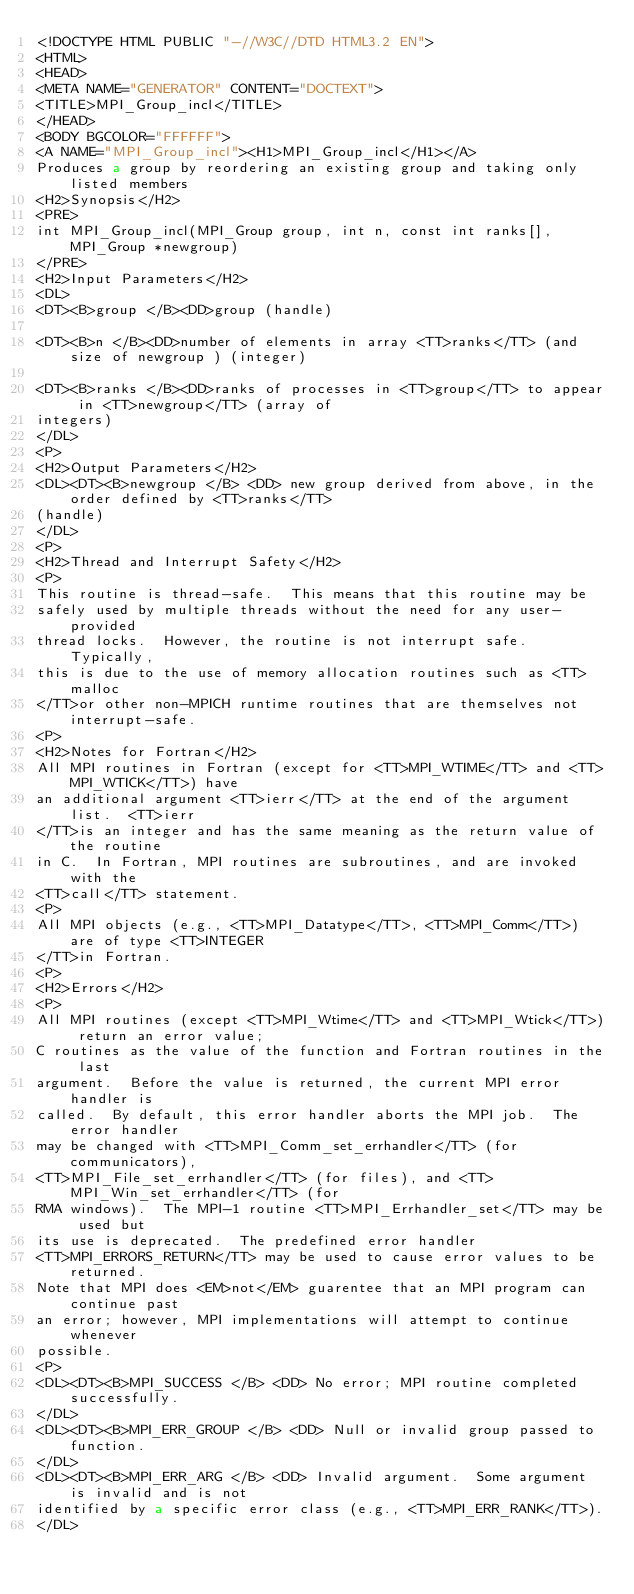<code> <loc_0><loc_0><loc_500><loc_500><_HTML_><!DOCTYPE HTML PUBLIC "-//W3C//DTD HTML3.2 EN">
<HTML>
<HEAD>
<META NAME="GENERATOR" CONTENT="DOCTEXT">
<TITLE>MPI_Group_incl</TITLE>
</HEAD>
<BODY BGCOLOR="FFFFFF">
<A NAME="MPI_Group_incl"><H1>MPI_Group_incl</H1></A>
Produces a group by reordering an existing group and taking only listed members 
<H2>Synopsis</H2>
<PRE>
int MPI_Group_incl(MPI_Group group, int n, const int ranks[], MPI_Group *newgroup)
</PRE>
<H2>Input Parameters</H2>
<DL>
<DT><B>group </B><DD>group (handle) 

<DT><B>n </B><DD>number of elements in array <TT>ranks</TT> (and size of newgroup ) (integer) 

<DT><B>ranks </B><DD>ranks of processes in <TT>group</TT> to appear in <TT>newgroup</TT> (array of 
integers) 
</DL>
<P>
<H2>Output Parameters</H2>
<DL><DT><B>newgroup </B> <DD> new group derived from above, in the order defined by <TT>ranks</TT> 
(handle) 
</DL>
<P>
<H2>Thread and Interrupt Safety</H2>
<P>
This routine is thread-safe.  This means that this routine may be
safely used by multiple threads without the need for any user-provided
thread locks.  However, the routine is not interrupt safe.  Typically,
this is due to the use of memory allocation routines such as <TT>malloc
</TT>or other non-MPICH runtime routines that are themselves not interrupt-safe.
<P>
<H2>Notes for Fortran</H2>
All MPI routines in Fortran (except for <TT>MPI_WTIME</TT> and <TT>MPI_WTICK</TT>) have
an additional argument <TT>ierr</TT> at the end of the argument list.  <TT>ierr
</TT>is an integer and has the same meaning as the return value of the routine
in C.  In Fortran, MPI routines are subroutines, and are invoked with the
<TT>call</TT> statement.
<P>
All MPI objects (e.g., <TT>MPI_Datatype</TT>, <TT>MPI_Comm</TT>) are of type <TT>INTEGER
</TT>in Fortran.
<P>
<H2>Errors</H2>
<P>
All MPI routines (except <TT>MPI_Wtime</TT> and <TT>MPI_Wtick</TT>) return an error value;
C routines as the value of the function and Fortran routines in the last
argument.  Before the value is returned, the current MPI error handler is
called.  By default, this error handler aborts the MPI job.  The error handler
may be changed with <TT>MPI_Comm_set_errhandler</TT> (for communicators),
<TT>MPI_File_set_errhandler</TT> (for files), and <TT>MPI_Win_set_errhandler</TT> (for
RMA windows).  The MPI-1 routine <TT>MPI_Errhandler_set</TT> may be used but
its use is deprecated.  The predefined error handler
<TT>MPI_ERRORS_RETURN</TT> may be used to cause error values to be returned.
Note that MPI does <EM>not</EM> guarentee that an MPI program can continue past
an error; however, MPI implementations will attempt to continue whenever
possible.
<P>
<DL><DT><B>MPI_SUCCESS </B> <DD> No error; MPI routine completed successfully.
</DL>
<DL><DT><B>MPI_ERR_GROUP </B> <DD> Null or invalid group passed to function.  
</DL>
<DL><DT><B>MPI_ERR_ARG </B> <DD> Invalid argument.  Some argument is invalid and is not
identified by a specific error class (e.g., <TT>MPI_ERR_RANK</TT>).
</DL></code> 